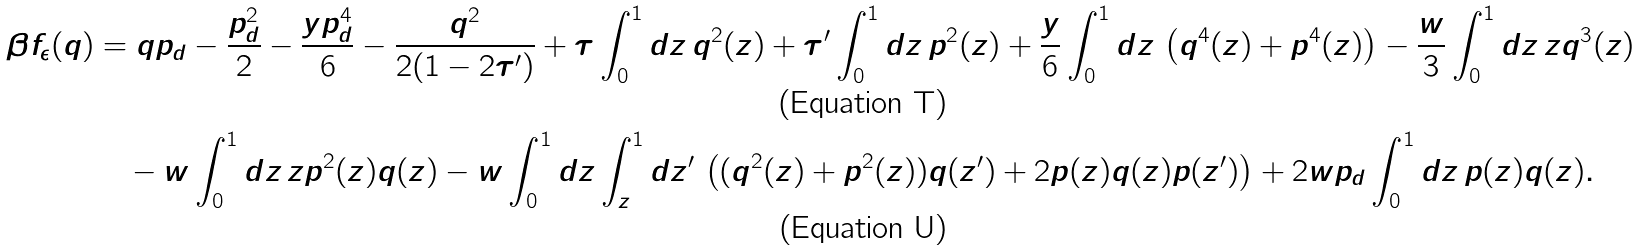<formula> <loc_0><loc_0><loc_500><loc_500>\beta f _ { \epsilon } ( q ) & = q p _ { d } - \frac { p _ { d } ^ { 2 } } { 2 } - \frac { y p _ { d } ^ { 4 } } { 6 } - \frac { q ^ { 2 } } { 2 ( 1 - 2 \tau ^ { \prime } ) } + \tau \int _ { 0 } ^ { 1 } d z \, q ^ { 2 } ( z ) + \tau ^ { \prime } \int _ { 0 } ^ { 1 } d z \, p ^ { 2 } ( z ) + \frac { y } { 6 } \int _ { 0 } ^ { 1 } d z \, \left ( q ^ { 4 } ( z ) + p ^ { 4 } ( z ) \right ) - \frac { w } { 3 } \int _ { 0 } ^ { 1 } d z \, z q ^ { 3 } ( z ) \\ & \quad - w \int _ { 0 } ^ { 1 } d z \, z p ^ { 2 } ( z ) q ( z ) - w \int _ { 0 } ^ { 1 } d z \int _ { z } ^ { 1 } d z ^ { \prime } \, \left ( ( q ^ { 2 } ( z ) + p ^ { 2 } ( z ) ) q ( z ^ { \prime } ) + 2 p ( z ) q ( z ) p ( z ^ { \prime } ) \right ) + 2 w p _ { d } \int _ { 0 } ^ { 1 } d z \, p ( z ) q ( z ) .</formula> 